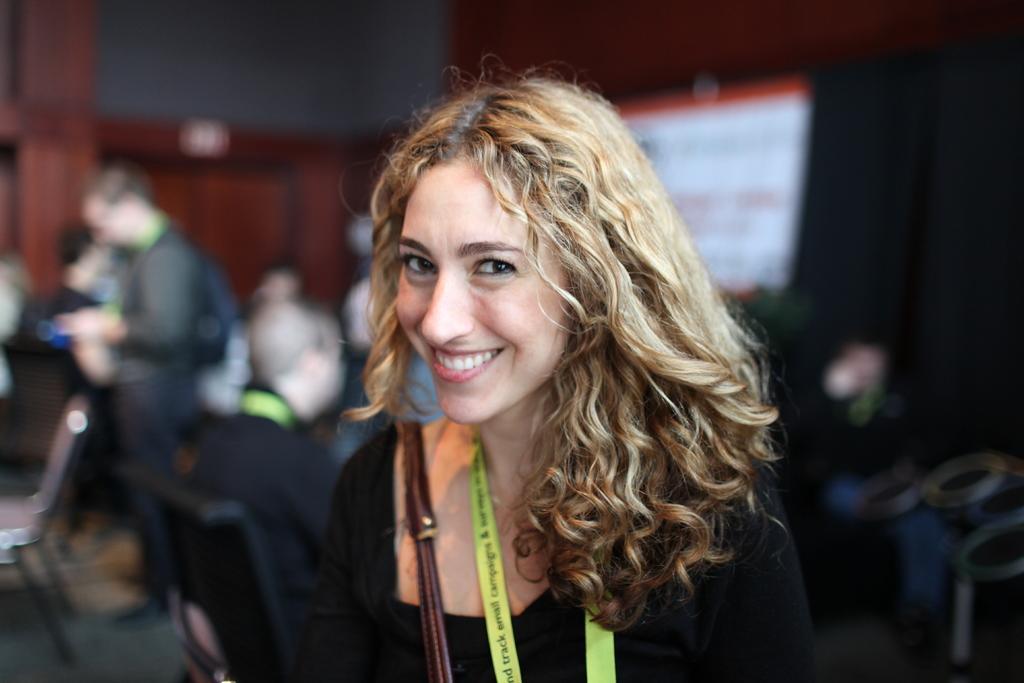Describe this image in one or two sentences. In this picture I can see a woman smiling, there are group of people, and there is blur background. 